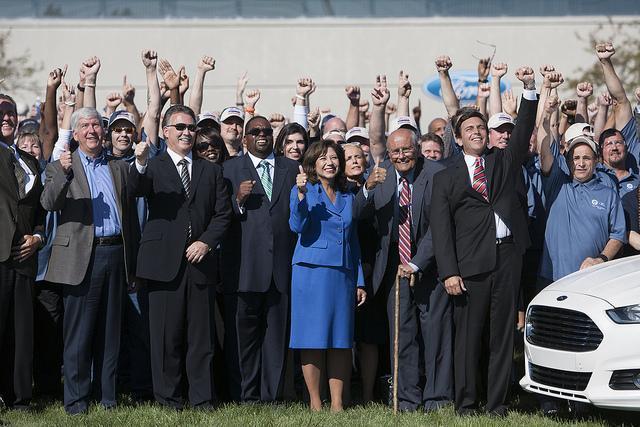How many people are there?
Give a very brief answer. 11. 